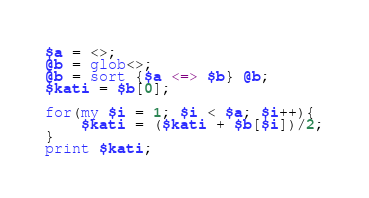Convert code to text. <code><loc_0><loc_0><loc_500><loc_500><_Perl_>$a = <>;
@b = glob<>;
@b = sort {$a <=> $b} @b;
$kati = $b[0];

for(my $i = 1; $i < $a; $i++){
	$kati = ($kati + $b[$i])/2;
}
print $kati;
</code> 